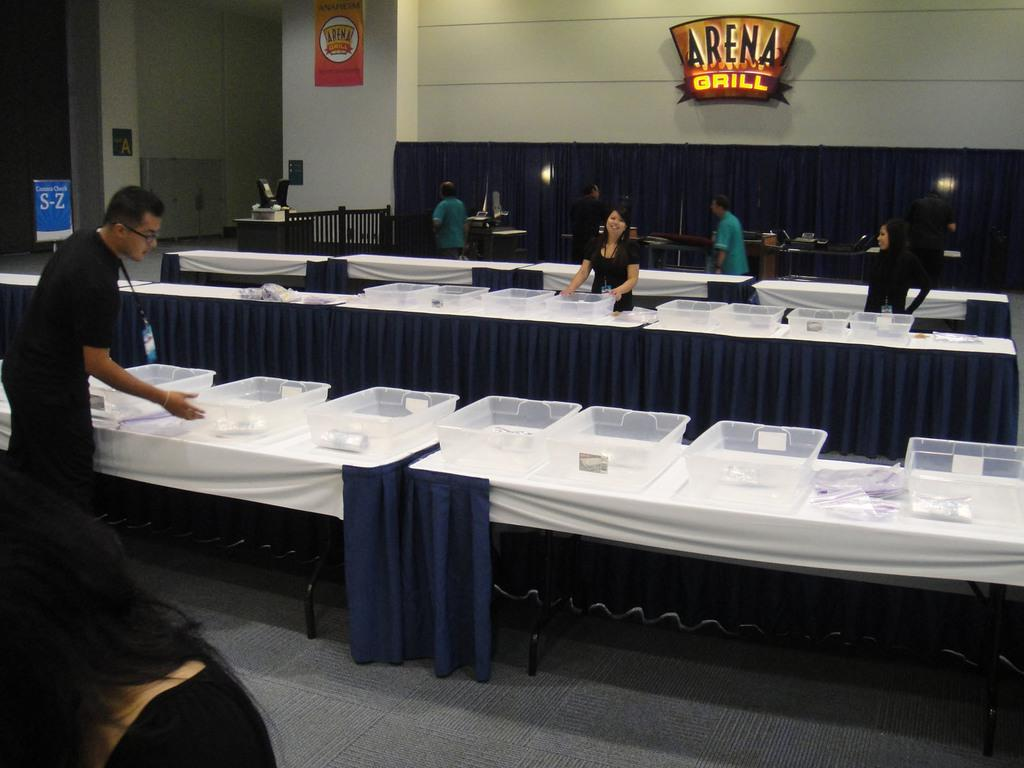What objects are on the tables in the image? There are plastic trays and covers on the tables. What are the people in the image doing? There are groups of people standing. What can be seen on the walls or other surfaces in the image? There are boards in the image. What type of window treatment is visible in the image? There are curtains in the image. Can you describe any other items or objects in the image? There are other unspecified items in the image. What type of advice is being given on the sack in the image? There is no sack present in the image, and therefore no advice can be given on it. Can you describe the vase on the table in the image? There is no vase present in the image; only plastic trays and covers are on the tables. 